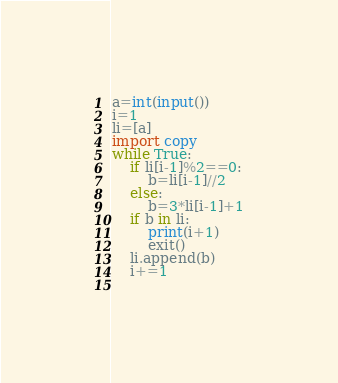<code> <loc_0><loc_0><loc_500><loc_500><_Python_>a=int(input())
i=1
li=[a]
import copy
while True:
    if li[i-1]%2==0:
        b=li[i-1]//2
    else:
        b=3*li[i-1]+1
    if b in li:
        print(i+1)
        exit()
    li.append(b)
    i+=1
        
</code> 